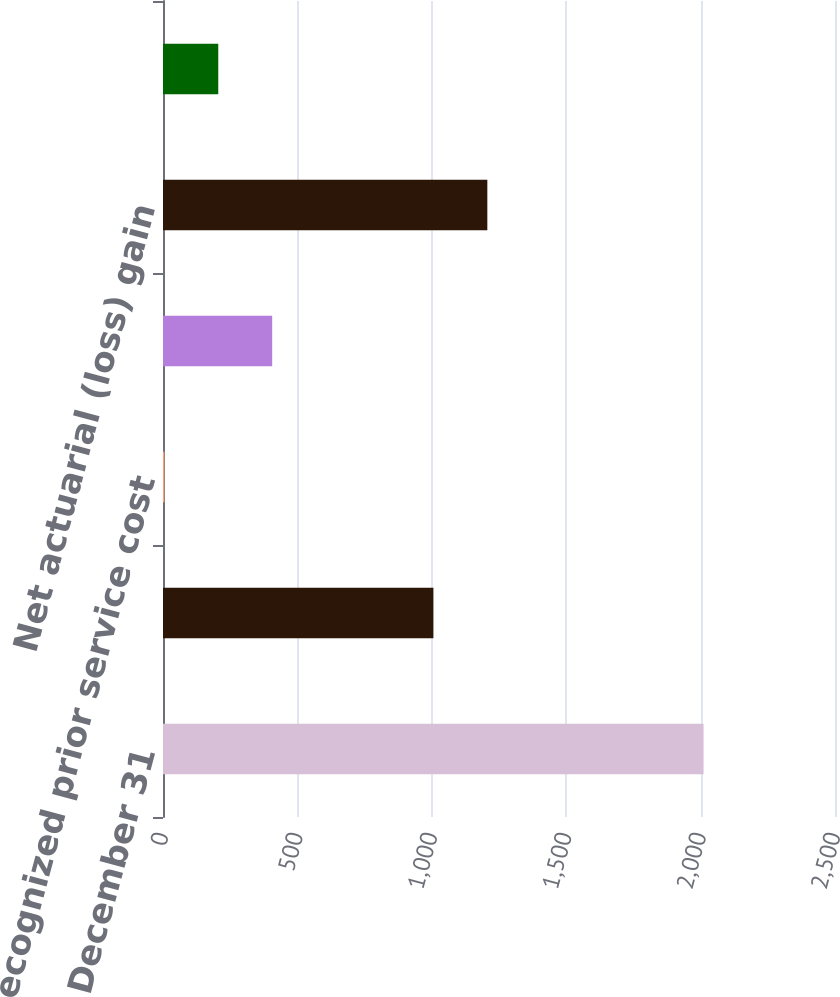Convert chart. <chart><loc_0><loc_0><loc_500><loc_500><bar_chart><fcel>December 31<fcel>Beginning balance in AOCI<fcel>Recognized prior service cost<fcel>Recognized net actuarial loss<fcel>Net actuarial (loss) gain<fcel>Translation gain (loss)<nl><fcel>2011<fcel>1006<fcel>5<fcel>406.2<fcel>1206.6<fcel>205.6<nl></chart> 